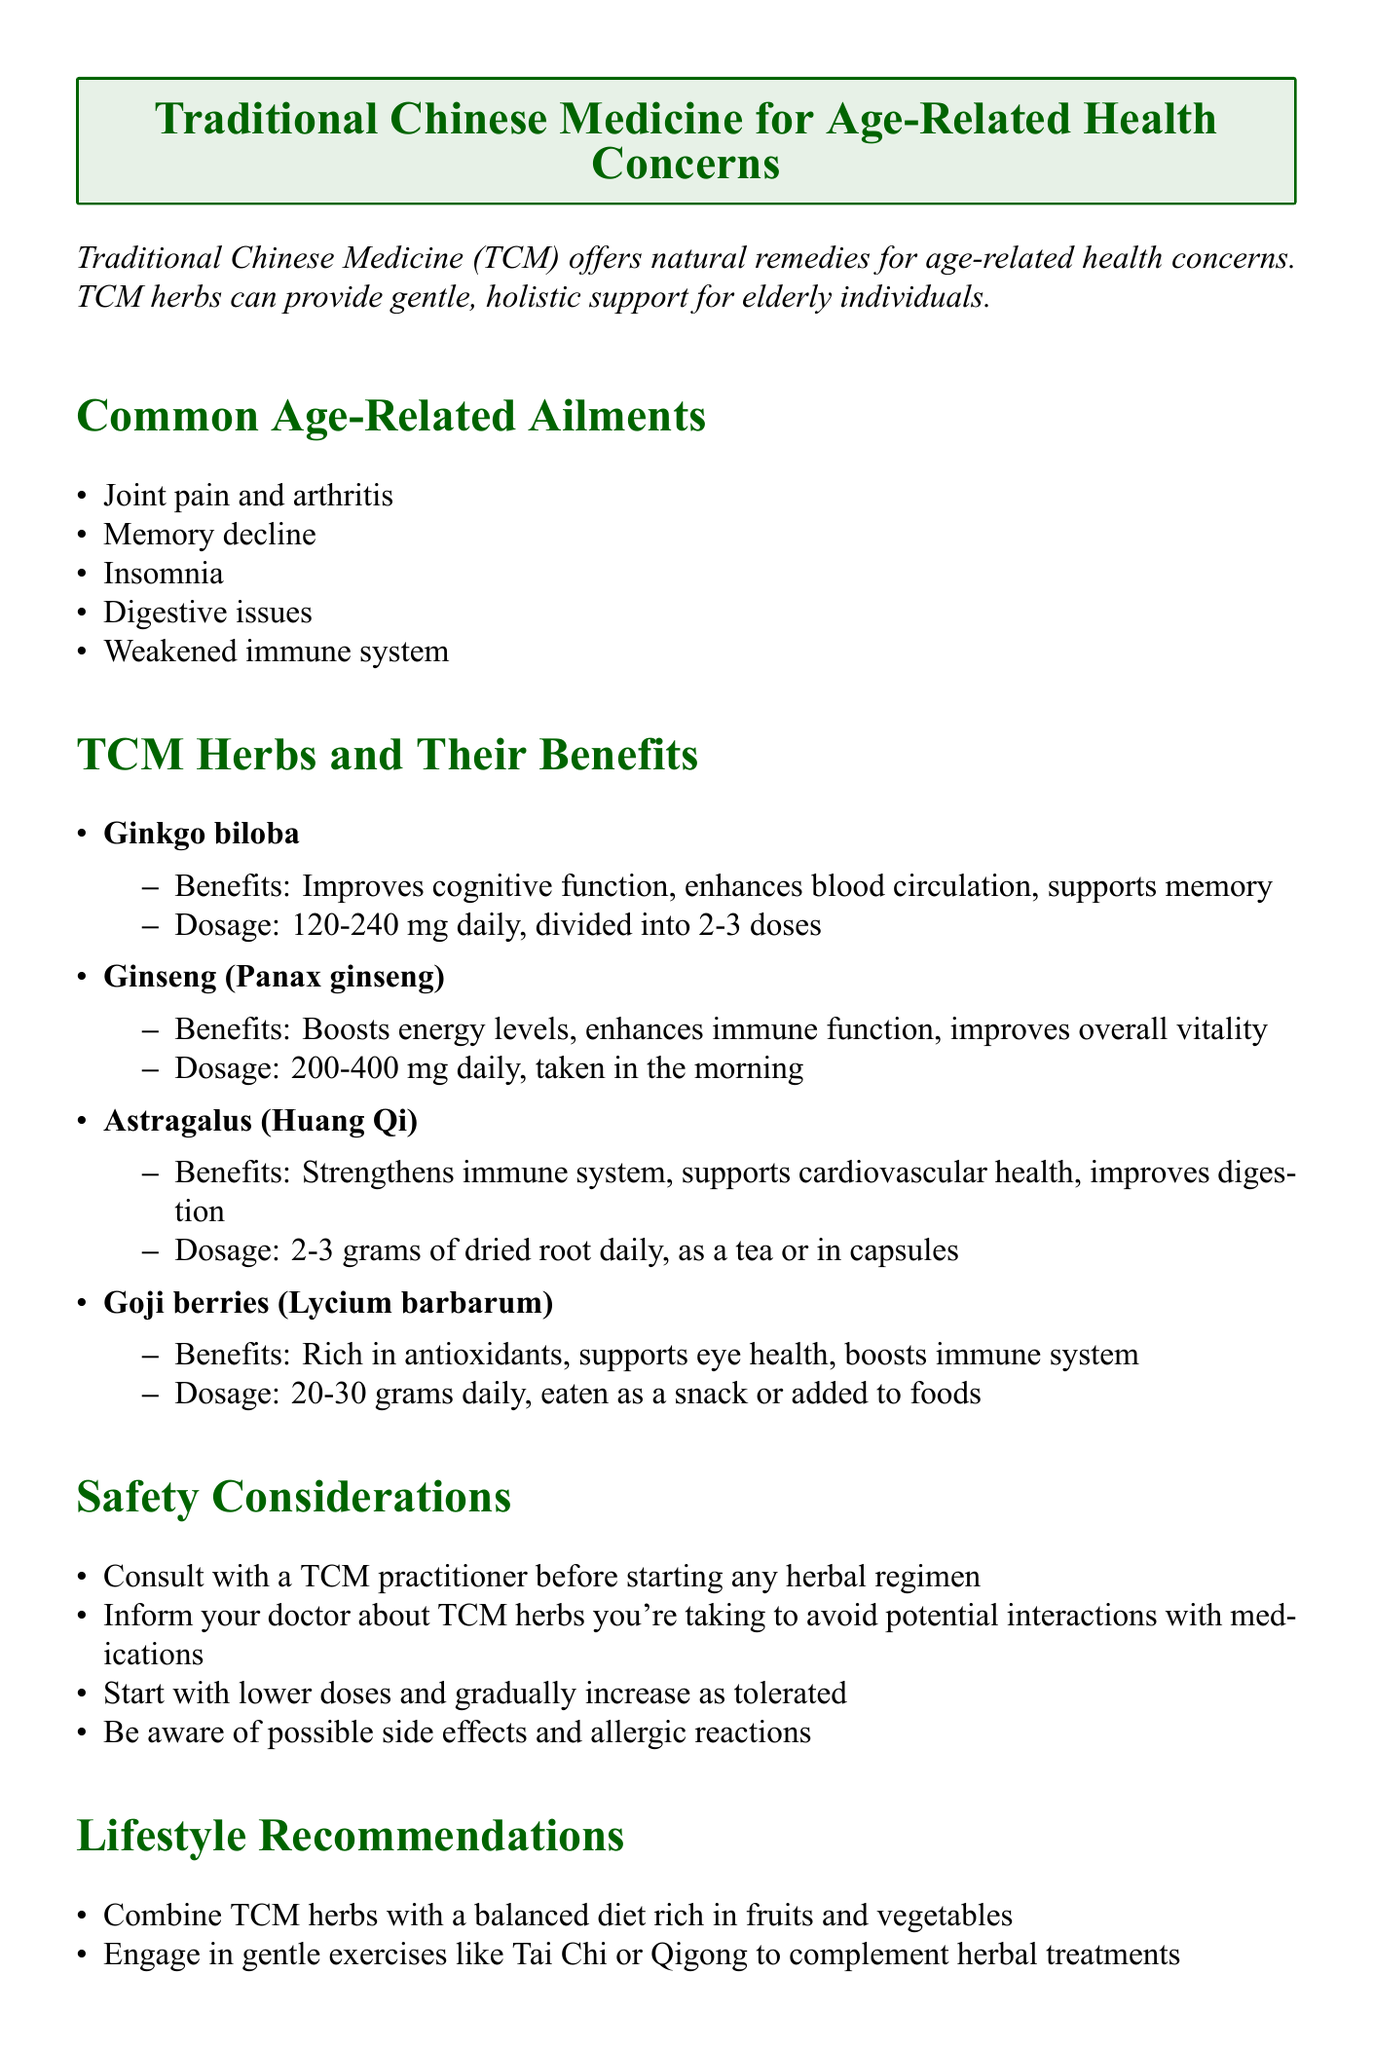What are the common age-related ailments mentioned? The document lists several common age-related ailments, including joint pain and arthritis, memory decline, insomnia, digestive issues, and weakened immune system.
Answer: Joint pain and arthritis, memory decline, insomnia, digestive issues, weakened immune system What is the recommended dosage for Ginkgo biloba? The document specifies a dosage for Ginkgo biloba, which is 120-240 mg daily, divided into 2-3 doses.
Answer: 120-240 mg daily, divided into 2-3 doses What are the benefits of Ginseng? The benefits of Ginseng (Panax ginseng) are listed as boosting energy levels, enhancing immune function, and improving overall vitality.
Answer: Boosts energy levels, enhances immune function, improves overall vitality How much Goji berries should be consumed daily? The document states that the recommended daily intake of Goji berries is 20-30 grams.
Answer: 20-30 grams daily What should be done before starting any herbal regimen? The recommended action is to consult with a TCM practitioner before starting any herbal regimen.
Answer: Consult with a TCM practitioner What lifestyle recommendation involves exercise? The document suggests engaging in gentle exercises like Tai Chi or Qigong to complement herbal treatments.
Answer: Tai Chi or Qigong What is the conclusion about TCM herbs? The conclusion summarizes the benefits of TCM herbs, indicating they offer natural support for age-related health concerns.
Answer: TCM herbs offer natural support for age-related health concerns 